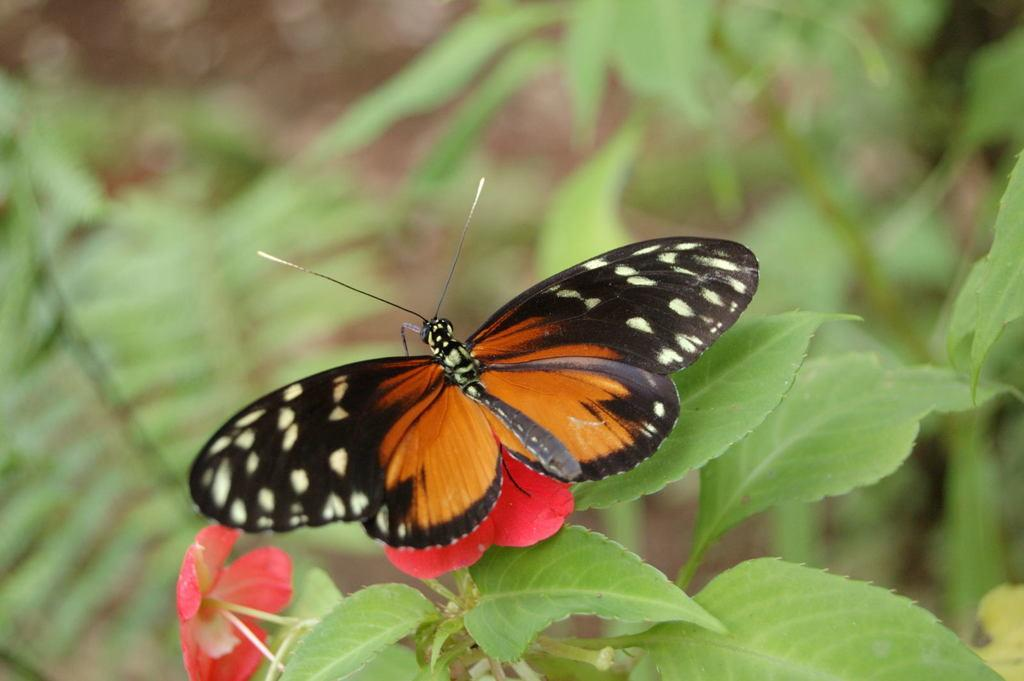What is the main subject of the image? There is a butterfly in the image. Where is the butterfly located? The butterfly is on a flower. What can be seen in the background of the image? There are leaves in the background of the image. How would you describe the background of the image? The background is blurred. What type of teaching method is being demonstrated in the image? There is no teaching method or activity present in the image; it features a butterfly on a flower. What kind of bottle can be seen in the image? There is no bottle present in the image. 